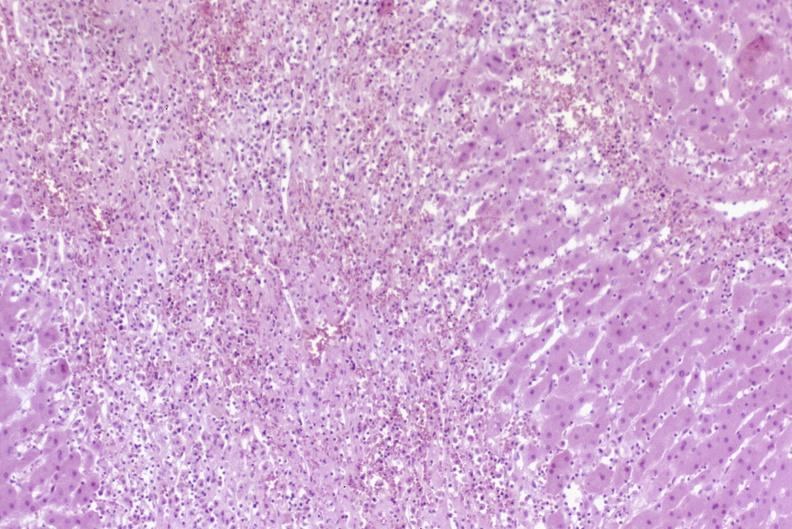what is present?
Answer the question using a single word or phrase. Hepatobiliary 